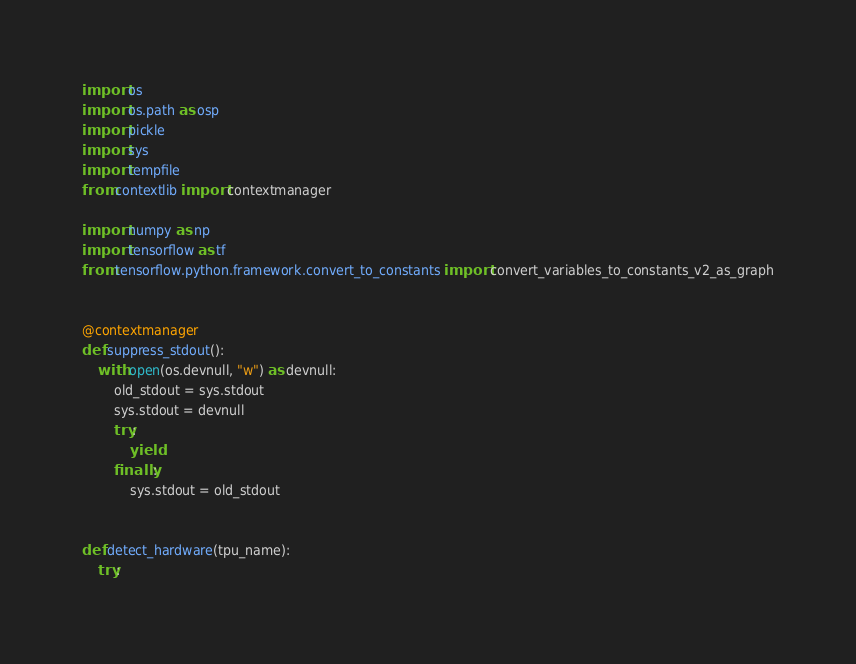Convert code to text. <code><loc_0><loc_0><loc_500><loc_500><_Python_>import os
import os.path as osp
import pickle
import sys
import tempfile
from contextlib import contextmanager

import numpy as np
import tensorflow as tf
from tensorflow.python.framework.convert_to_constants import convert_variables_to_constants_v2_as_graph


@contextmanager
def suppress_stdout():
    with open(os.devnull, "w") as devnull:
        old_stdout = sys.stdout
        sys.stdout = devnull
        try:
            yield
        finally:
            sys.stdout = old_stdout


def detect_hardware(tpu_name):
    try:</code> 